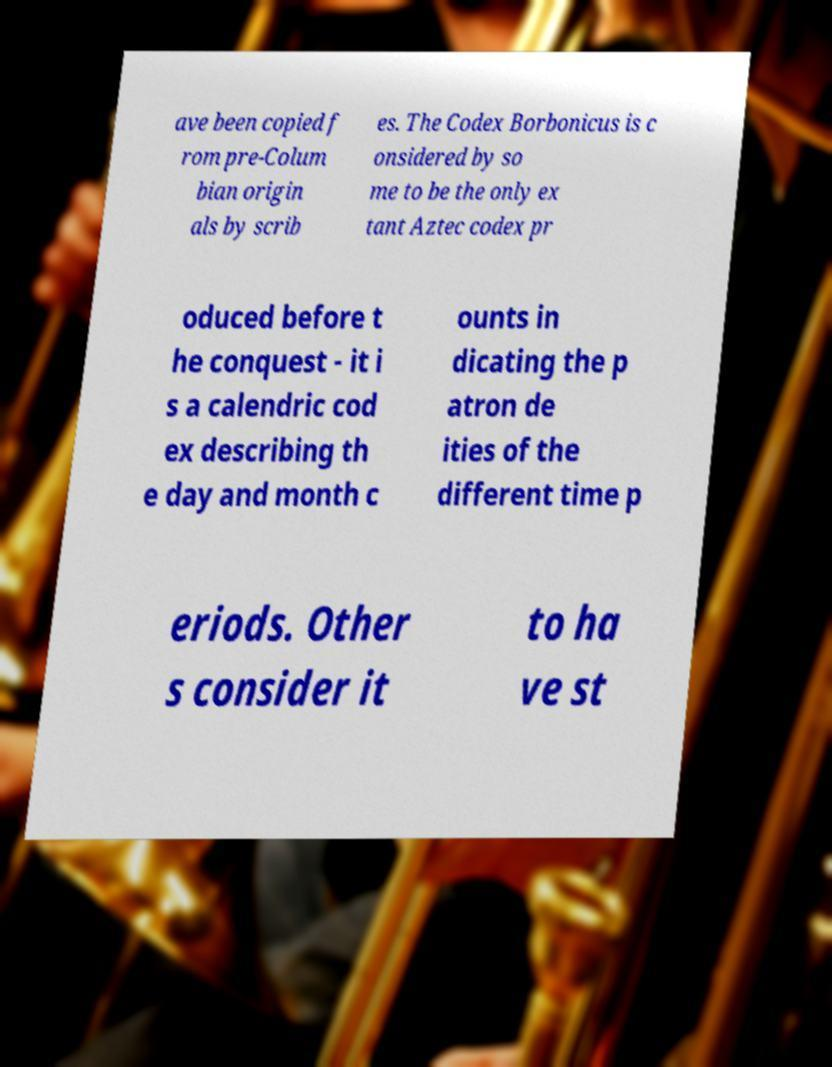Could you assist in decoding the text presented in this image and type it out clearly? ave been copied f rom pre-Colum bian origin als by scrib es. The Codex Borbonicus is c onsidered by so me to be the only ex tant Aztec codex pr oduced before t he conquest - it i s a calendric cod ex describing th e day and month c ounts in dicating the p atron de ities of the different time p eriods. Other s consider it to ha ve st 